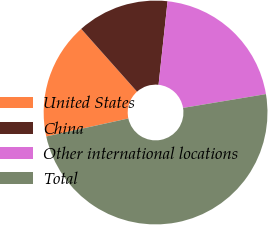<chart> <loc_0><loc_0><loc_500><loc_500><pie_chart><fcel>United States<fcel>China<fcel>Other international locations<fcel>Total<nl><fcel>16.87%<fcel>13.28%<fcel>20.66%<fcel>49.19%<nl></chart> 